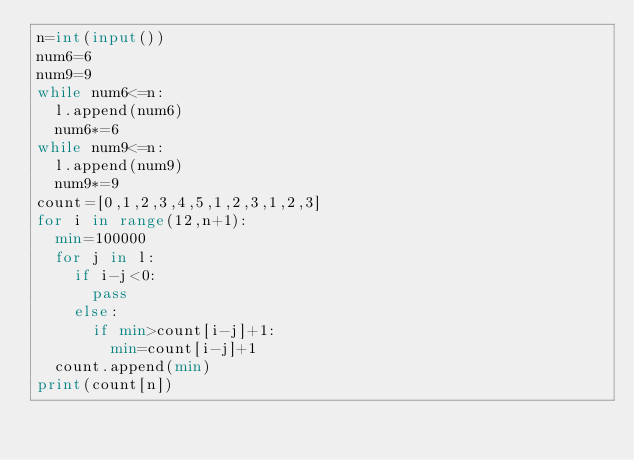<code> <loc_0><loc_0><loc_500><loc_500><_Python_>n=int(input())
num6=6
num9=9
while num6<=n:
  l.append(num6)
  num6*=6
while num9<=n:
  l.append(num9)
  num9*=9
count=[0,1,2,3,4,5,1,2,3,1,2,3]
for i in range(12,n+1):
  min=100000
  for j in l:
    if i-j<0:
      pass
    else:
      if min>count[i-j]+1:
        min=count[i-j]+1
  count.append(min)
print(count[n])</code> 